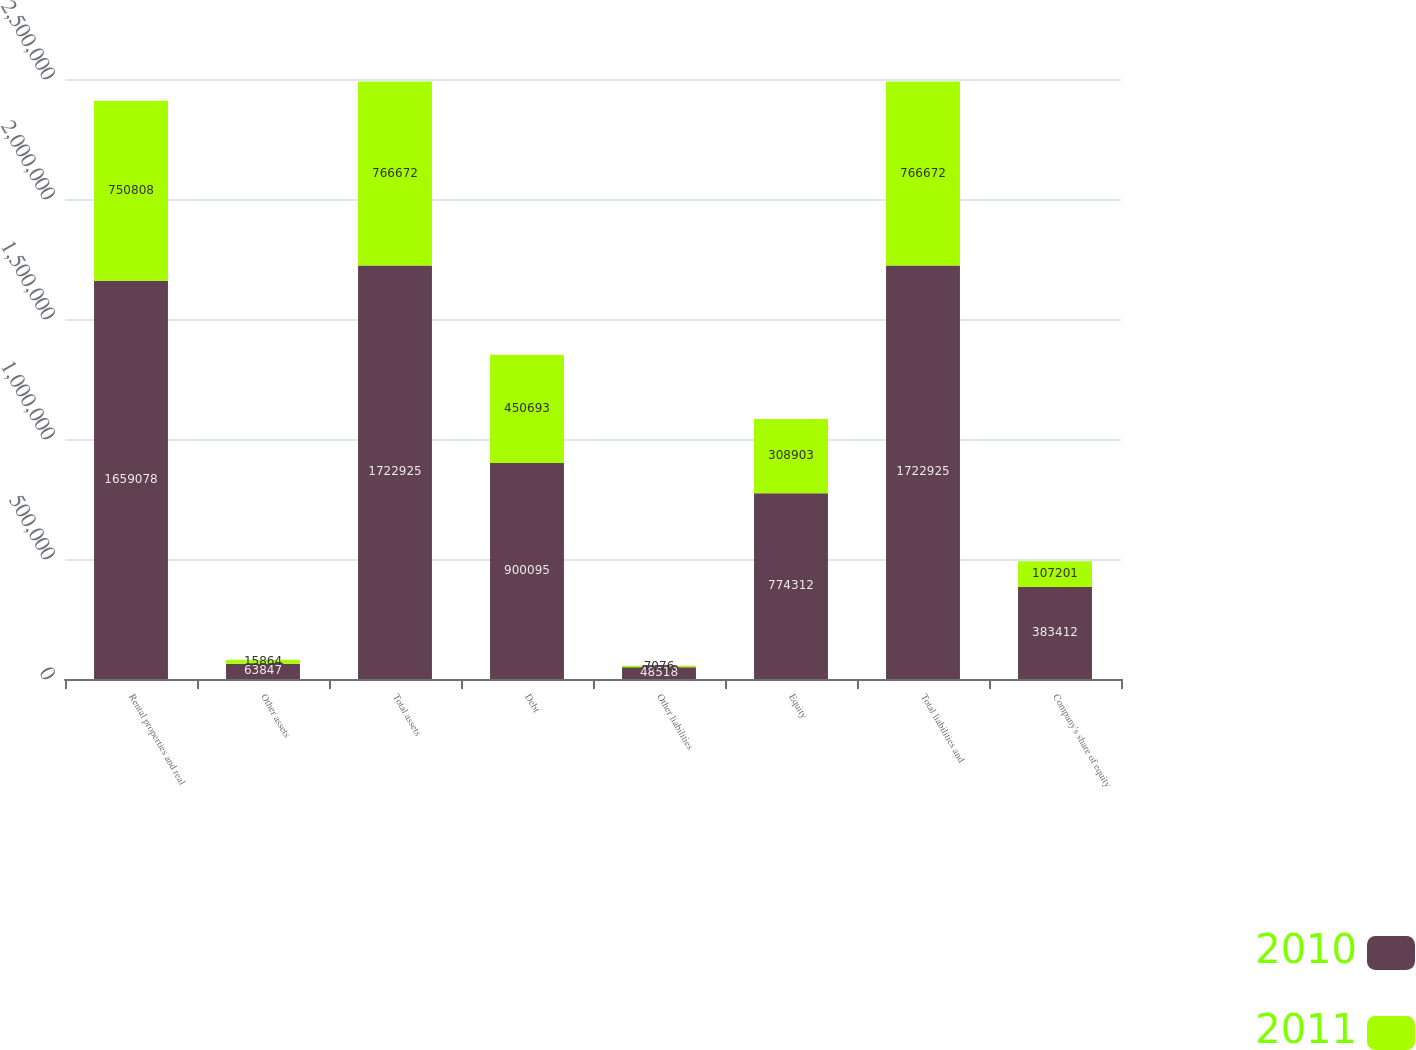Convert chart. <chart><loc_0><loc_0><loc_500><loc_500><stacked_bar_chart><ecel><fcel>Rental properties and real<fcel>Other assets<fcel>Total assets<fcel>Debt<fcel>Other liabilities<fcel>Equity<fcel>Total liabilities and<fcel>Company's share of equity<nl><fcel>2010<fcel>1.65908e+06<fcel>63847<fcel>1.72292e+06<fcel>900095<fcel>48518<fcel>774312<fcel>1.72292e+06<fcel>383412<nl><fcel>2011<fcel>750808<fcel>15864<fcel>766672<fcel>450693<fcel>7076<fcel>308903<fcel>766672<fcel>107201<nl></chart> 